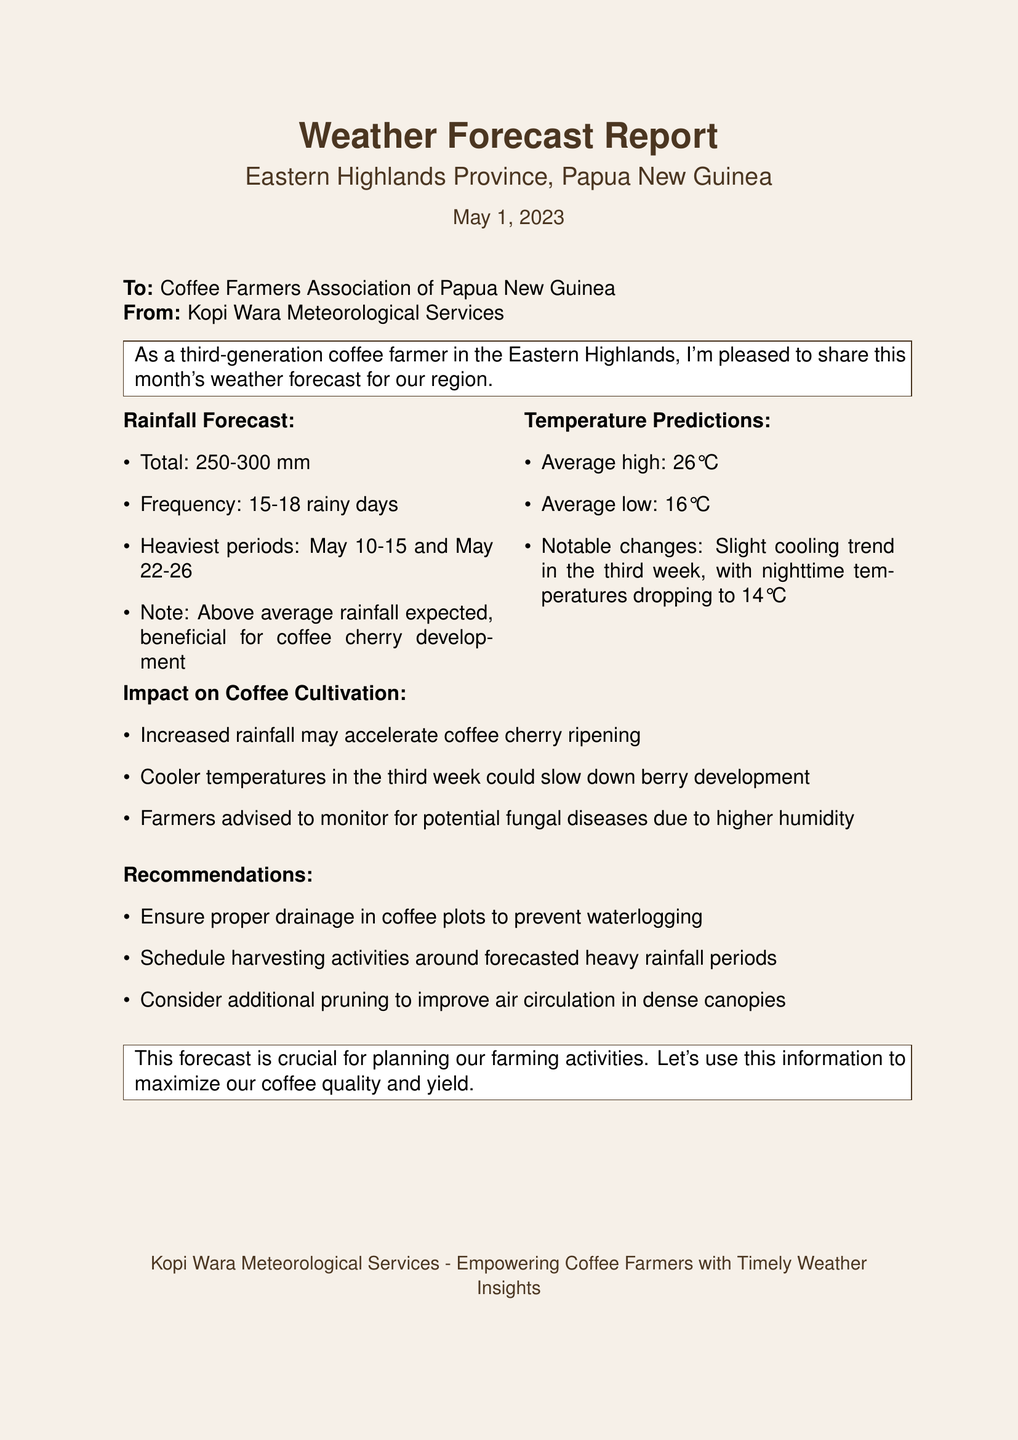what is the total expected rainfall for the month? The total expected rainfall is stated in the document as between 250-300 mm.
Answer: 250-300 mm how many rainy days are predicted this month? The document specifies that there will be 15-18 rainy days.
Answer: 15-18 rainy days when are the heaviest periods of rainfall expected? The document lists the specific dates for the heaviest rainfall as May 10-15 and May 22-26.
Answer: May 10-15 and May 22-26 what is the average high temperature predicted for the month? The forecast states that the average high temperature will be 26°C.
Answer: 26°C what notable temperature change occurs in the third week? The document mentions a cooling trend with nighttime temperatures dropping to 14°C.
Answer: 14°C how will increased rainfall affect coffee cherry ripening? The document indicates that increased rainfall may accelerate coffee cherry ripening.
Answer: accelerate coffee cherry ripening what recommendations are given for coffee plot management? The document suggests ensuring proper drainage to prevent waterlogging.
Answer: ensure proper drainage what potential issue should farmers monitor due to higher humidity? The document advises monitoring for potential fungal diseases due to higher humidity.
Answer: fungal diseases who is the sender of this weather forecast report? The report is sent from Kopi Wara Meteorological Services.
Answer: Kopi Wara Meteorological Services 